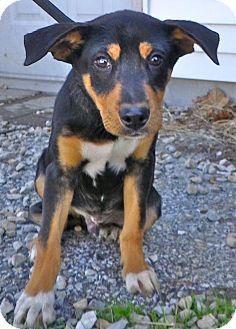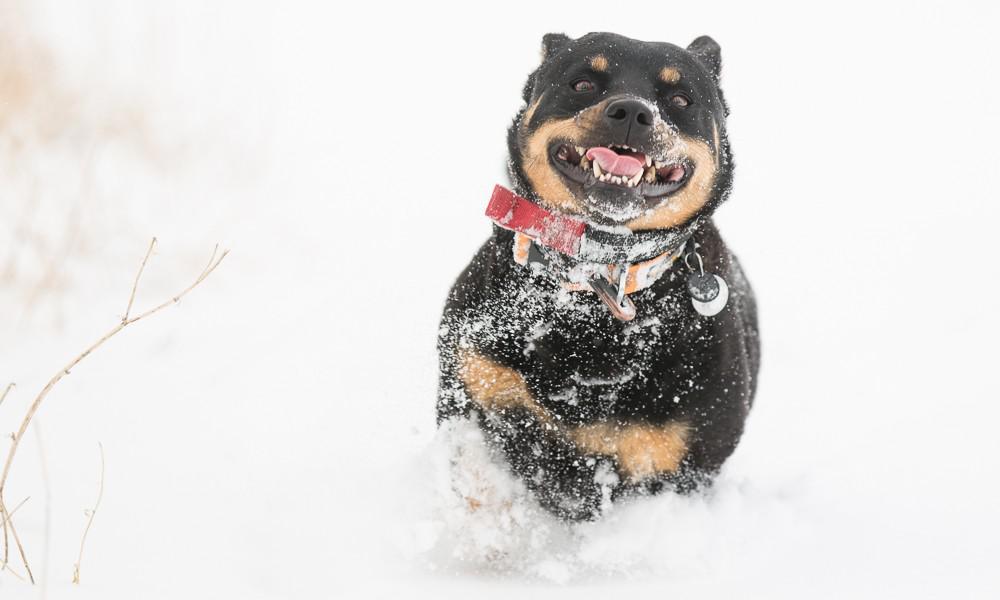The first image is the image on the left, the second image is the image on the right. Analyze the images presented: Is the assertion "A dog is sitting on carpet." valid? Answer yes or no. No. The first image is the image on the left, the second image is the image on the right. Evaluate the accuracy of this statement regarding the images: "In at least one image there is a black and brown dog leaning right with its head tilted forward right.". Is it true? Answer yes or no. Yes. 